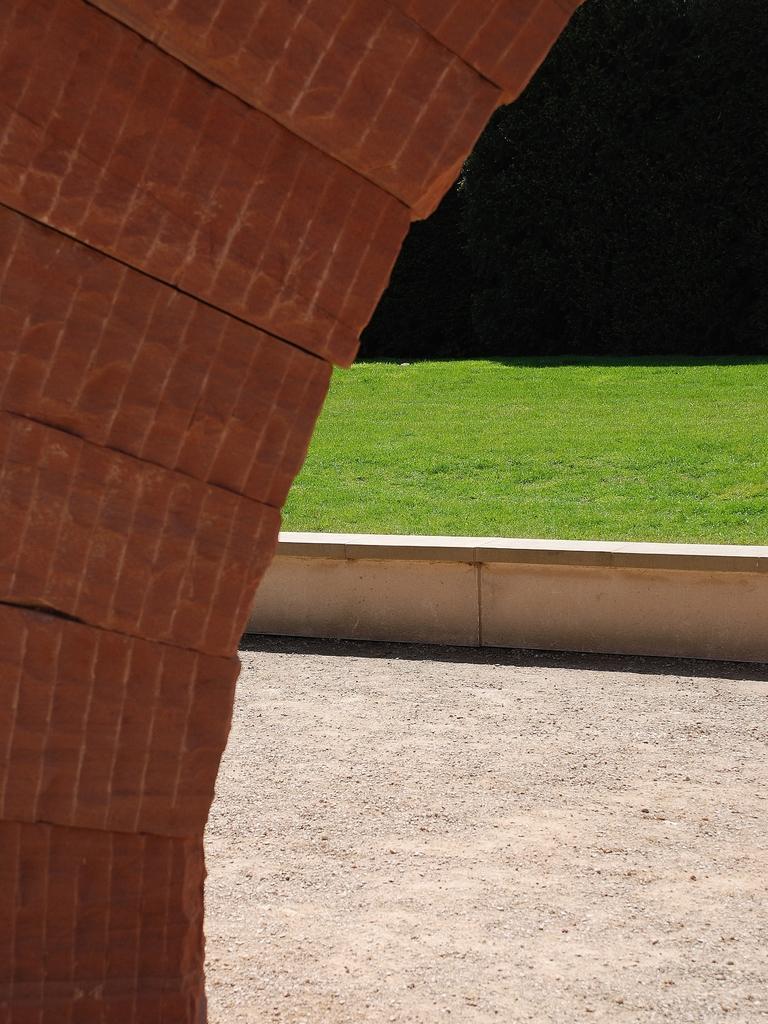How would you summarize this image in a sentence or two? On the left side, there is an arch made with bricks. In the background, there is a small wall. Beside this wall, there is a road and grass on the ground. And the background is dark in color. 